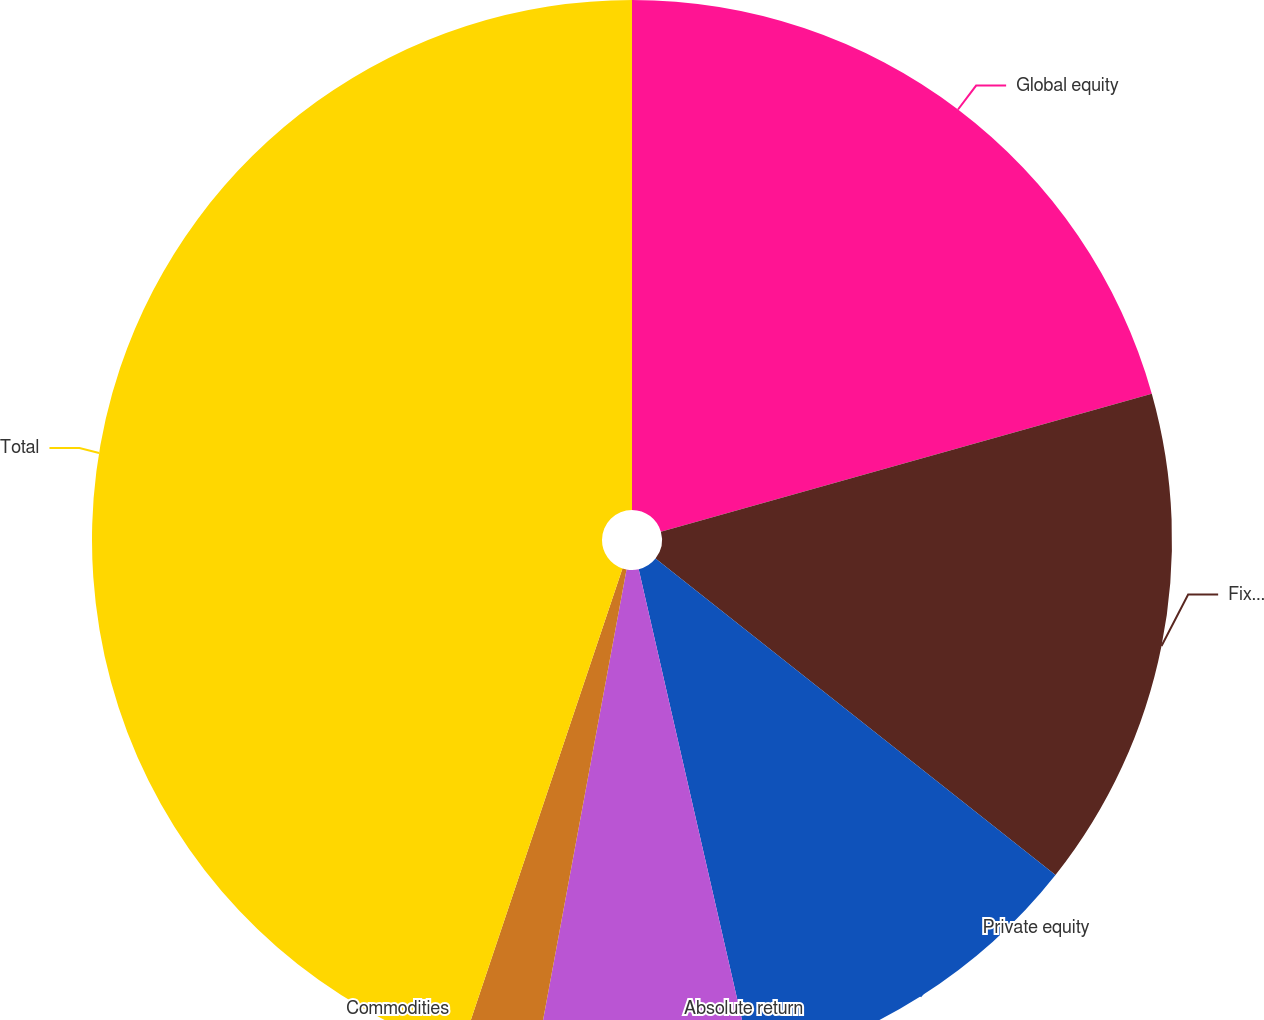Convert chart to OTSL. <chart><loc_0><loc_0><loc_500><loc_500><pie_chart><fcel>Global equity<fcel>Fixed income<fcel>Private equity<fcel>Absolute return<fcel>Commodities<fcel>Total<nl><fcel>20.63%<fcel>15.02%<fcel>10.76%<fcel>6.5%<fcel>2.24%<fcel>44.84%<nl></chart> 